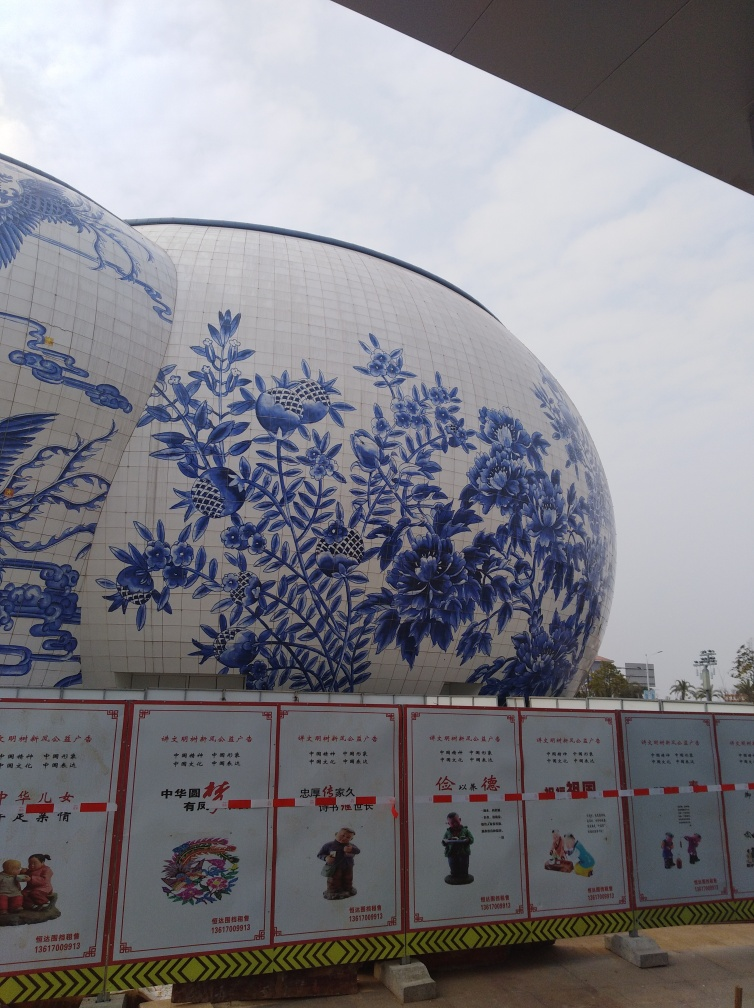Is there any noticeable distortion in the image?
 No 